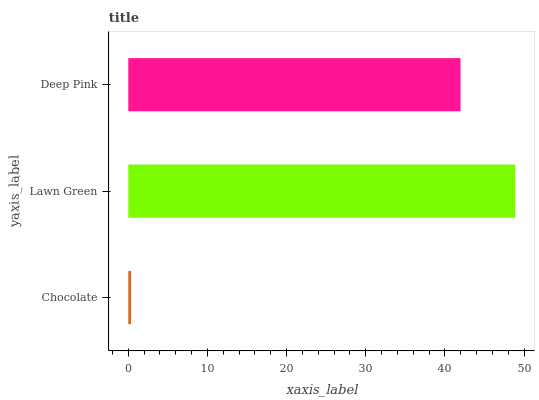Is Chocolate the minimum?
Answer yes or no. Yes. Is Lawn Green the maximum?
Answer yes or no. Yes. Is Deep Pink the minimum?
Answer yes or no. No. Is Deep Pink the maximum?
Answer yes or no. No. Is Lawn Green greater than Deep Pink?
Answer yes or no. Yes. Is Deep Pink less than Lawn Green?
Answer yes or no. Yes. Is Deep Pink greater than Lawn Green?
Answer yes or no. No. Is Lawn Green less than Deep Pink?
Answer yes or no. No. Is Deep Pink the high median?
Answer yes or no. Yes. Is Deep Pink the low median?
Answer yes or no. Yes. Is Chocolate the high median?
Answer yes or no. No. Is Lawn Green the low median?
Answer yes or no. No. 